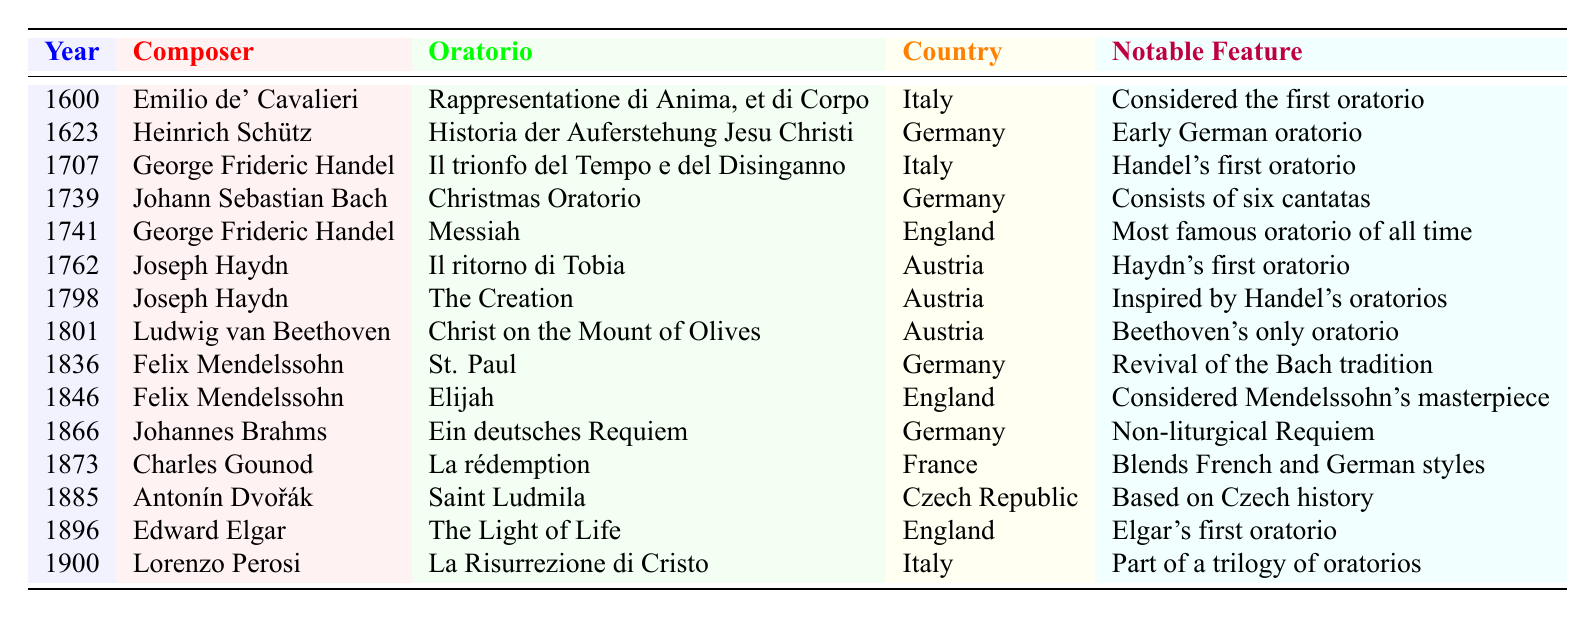What is the year of the composition of the oratorio "Messiah"? "Messiah" was composed by George Frideric Handel in 1741, as indicated in the table.
Answer: 1741 Who composed the earliest oratorio listed in the table? The earliest oratorio listed is "Rappresentatione di Anima, et di Corpo," composed by Emilio de' Cavalieri in 1600.
Answer: Emilio de' Cavalieri Which country is associated with the oratorio "The Creation"? The table indicates that "The Creation" was composed in Austria by Joseph Haydn.
Answer: Austria How many oratorios listed were composed by Felix Mendelssohn? There are two oratorios by Felix Mendelssohn in the table: "St. Paul" (1836) and "Elijah" (1846), which counts to two.
Answer: 2 Which oratorio is considered "Mendelssohn's masterpiece"? According to the table, "Elijah," composed in 1846, is noted as Mendelssohn’s masterpiece.
Answer: Elijah Was "Ein deutsches Requiem" a liturgical composition? The table states that "Ein deutsches Requiem" by Johannes Brahms is a non-liturgical Requiem, making the statement false.
Answer: No What is the notable feature of the oratorio "La rédemption"? According to the table, "La rédemption" by Charles Gounod is described as blending French and German styles.
Answer: Blends French and German styles What is the most recent oratorio listed in the table? The most recent oratorio in the table is "La Risurrezione di Cristo," composed by Lorenzo Perosi in 1900.
Answer: La Risurrezione di Cristo List the composers of the oratorios composed in the 1700s. The composers listed for the 1700s are: George Frideric Handel (1707, 1741), Johann Sebastian Bach (1739), and Joseph Haydn (1762, 1798).
Answer: Handel, Bach, Haydn Which composer had two major works listed in two different countries? Felix Mendelssohn composed oratorios in both Germany ("St. Paul") and England ("Elijah"), fulfilling this criteria.
Answer: Felix Mendelssohn Find the difference in years between the compositions of "Christmas Oratorio" and "La risurrezione di Cristo." "Christmas Oratorio" was composed in 1739 and "La risurrezione di Cristo" in 1900. The difference is 1900 - 1739 = 161 years.
Answer: 161 years 